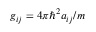<formula> <loc_0><loc_0><loc_500><loc_500>g _ { i j } = 4 \pi \hbar { ^ } { 2 } a _ { i j } / m</formula> 